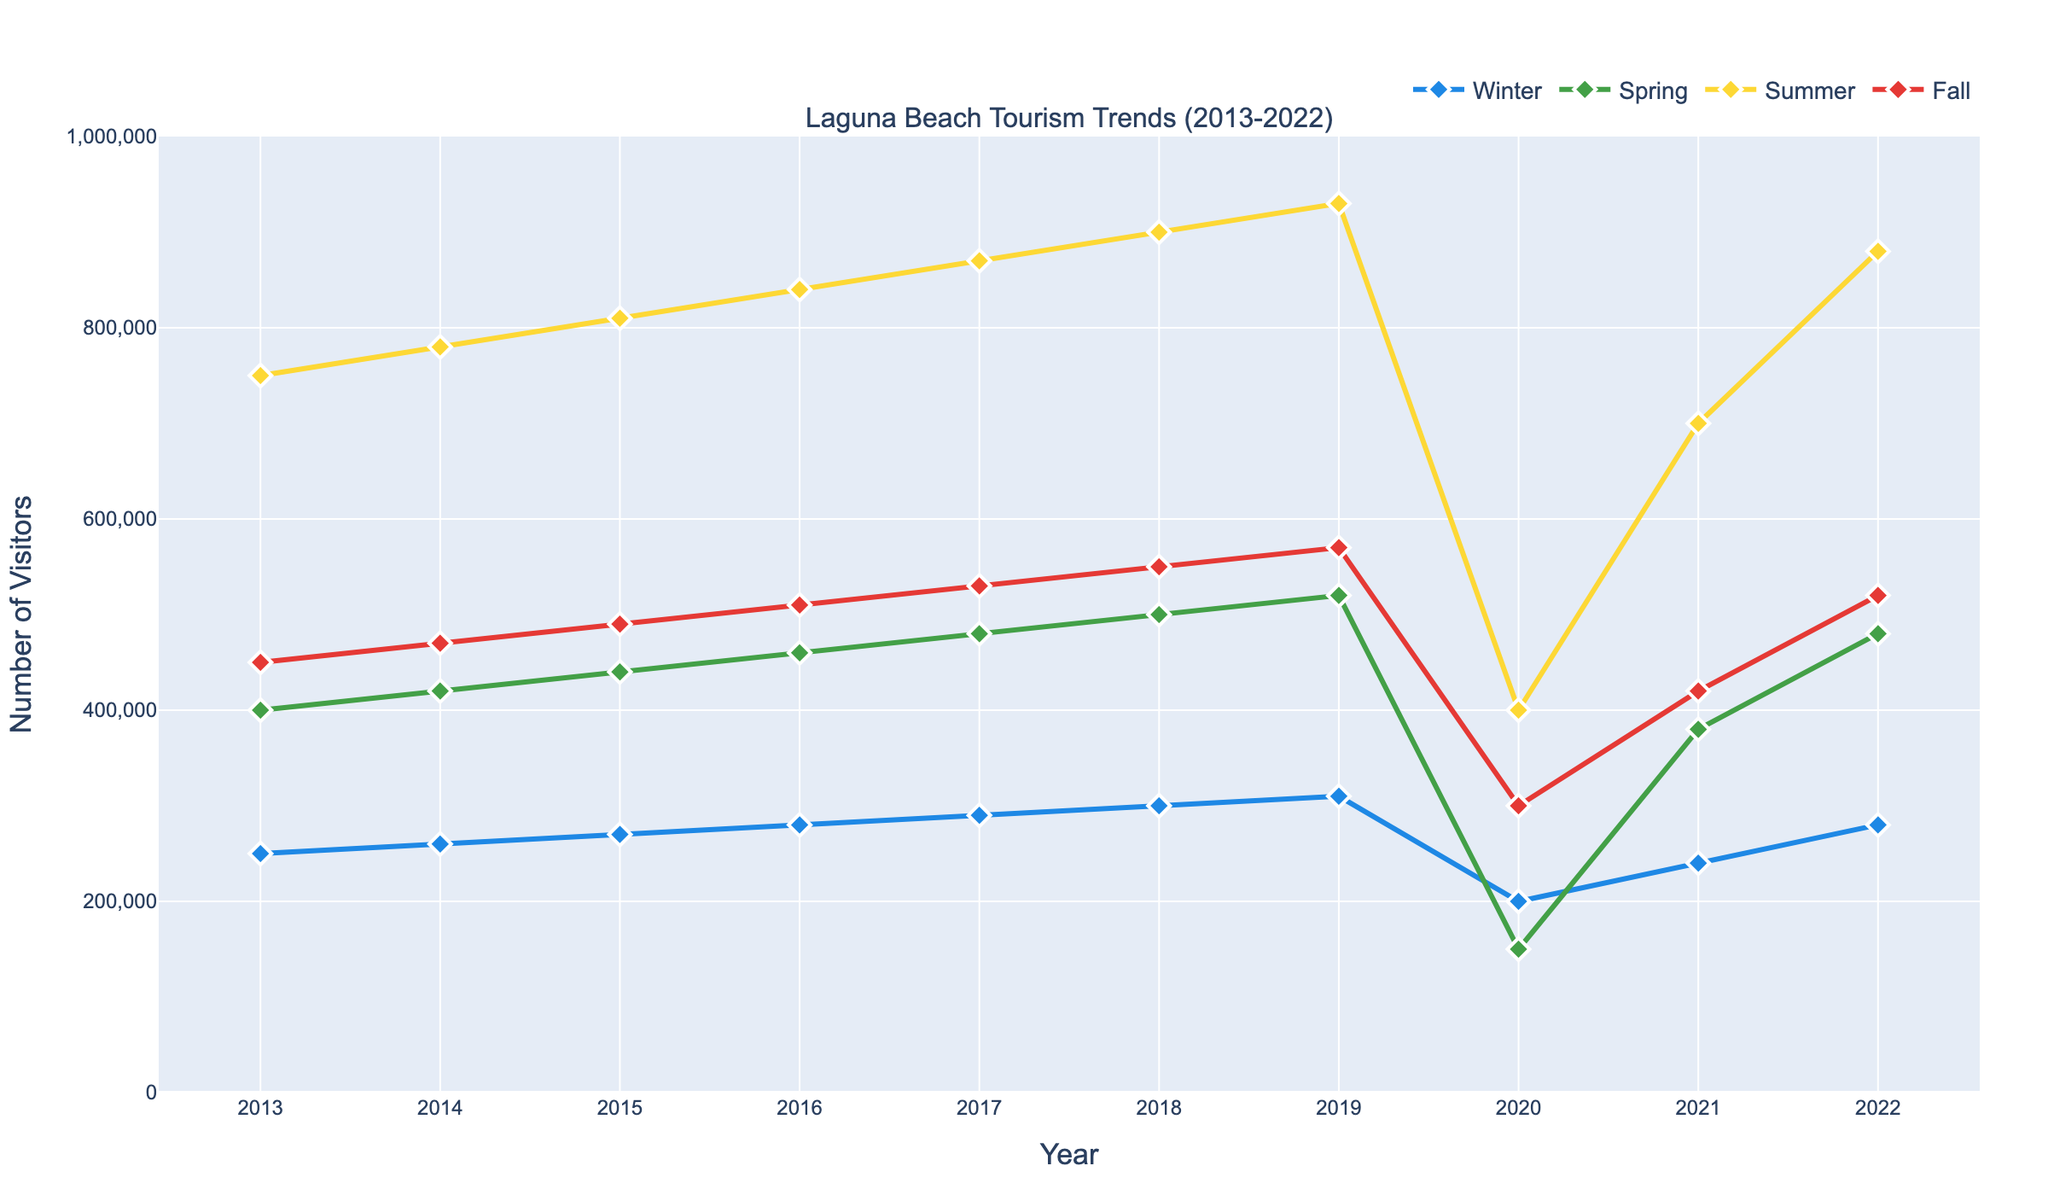Which season had the highest number of visitors in 2018? Look at the data points for each season in 2018; Summer had 900,000 visitors, which is the highest among the seasons for that year.
Answer: Summer How did the number of visitors in Winter 2020 compare to Winter 2019? The number of visitors in Winter 2020 (200,000) was less than Winter 2019 (310,000).
Answer: Less What is the overall trend in Summer visitor numbers from 2013 to 2022? Starting in 2013, the number of Summer visitors increased consistently each year until it dropped significantly in 2020, then rebounded and continued its increase in 2021 and 2022.
Answer: Increasing, with a dip in 2020 What was the total number of visitors across all seasons in 2020? Sum the visitor numbers for each season in 2020: 200,000 + 150,000 + 400,000 + 300,000 = 1,050,000.
Answer: 1,050,000 Which year experienced the largest drop in Spring visitors, and by how much? From 2019 to 2020, Spring visitors dropped from 520,000 to 150,000, which is the largest drop: 520,000 - 150,000 = 370,000.
Answer: 2020, by 370,000 What's the average number of Fall visitors between 2015 and 2017? Sum the Fall visitors for 2015, 2016, and 2017: 490,000 + 510,000 + 530,000 = 1,530,000. Then divide by 3: 1,530,000 / 3 = 510,000.
Answer: 510,000 Compare the trend in Winter visitors to Spring visitors from 2013 to 2022. Winter visitors show a steady increase with a dip in 2020 and recovery afterward. Similarly, Spring visitors show a steady increase, a large dip in 2020, and recovery afterward. Both trends are similar, with drops in 2020 due to likely external factors.
Answer: Similar trends, with both showing steady increases, dips in 2020, and recovery afterward 